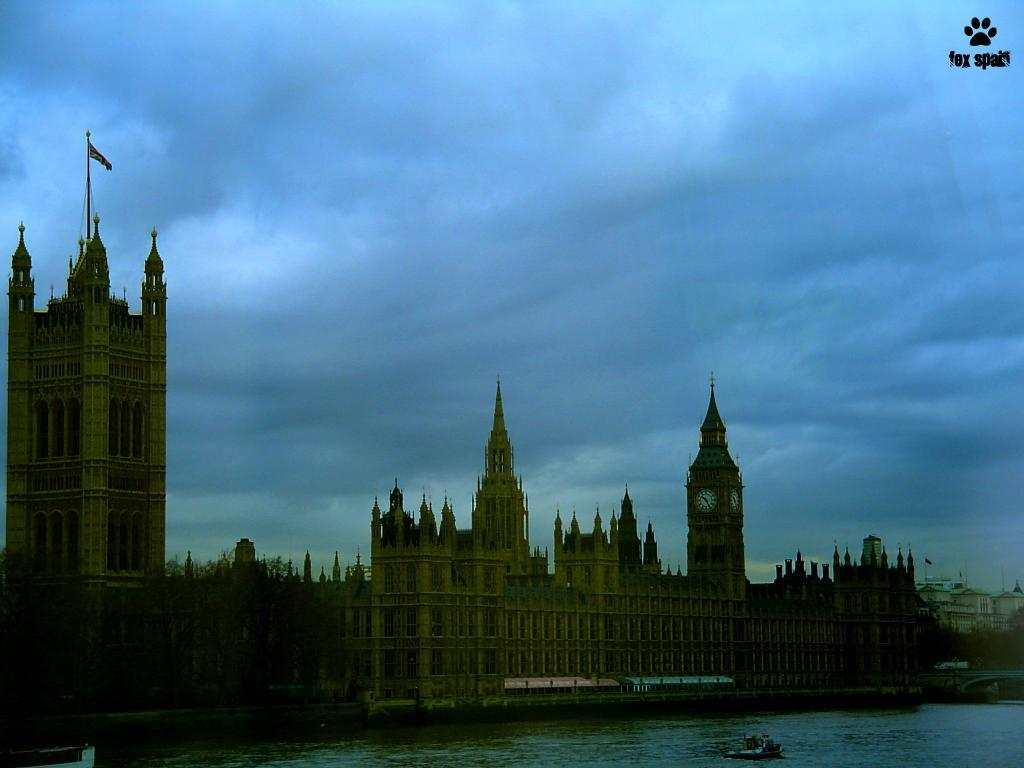What type of structures can be seen in the image? There are buildings in the image. Is there any specific building that stands out? Yes, there is a clock tower in the image. What can be seen in the background of the image? The sky is visible in the background of the image. What is the color of the sky in the image? The color of the sky is blue. How many cars are parked in front of the clock tower in the image? There are no cars visible in the image; it only features buildings, a clock tower, and the sky. 